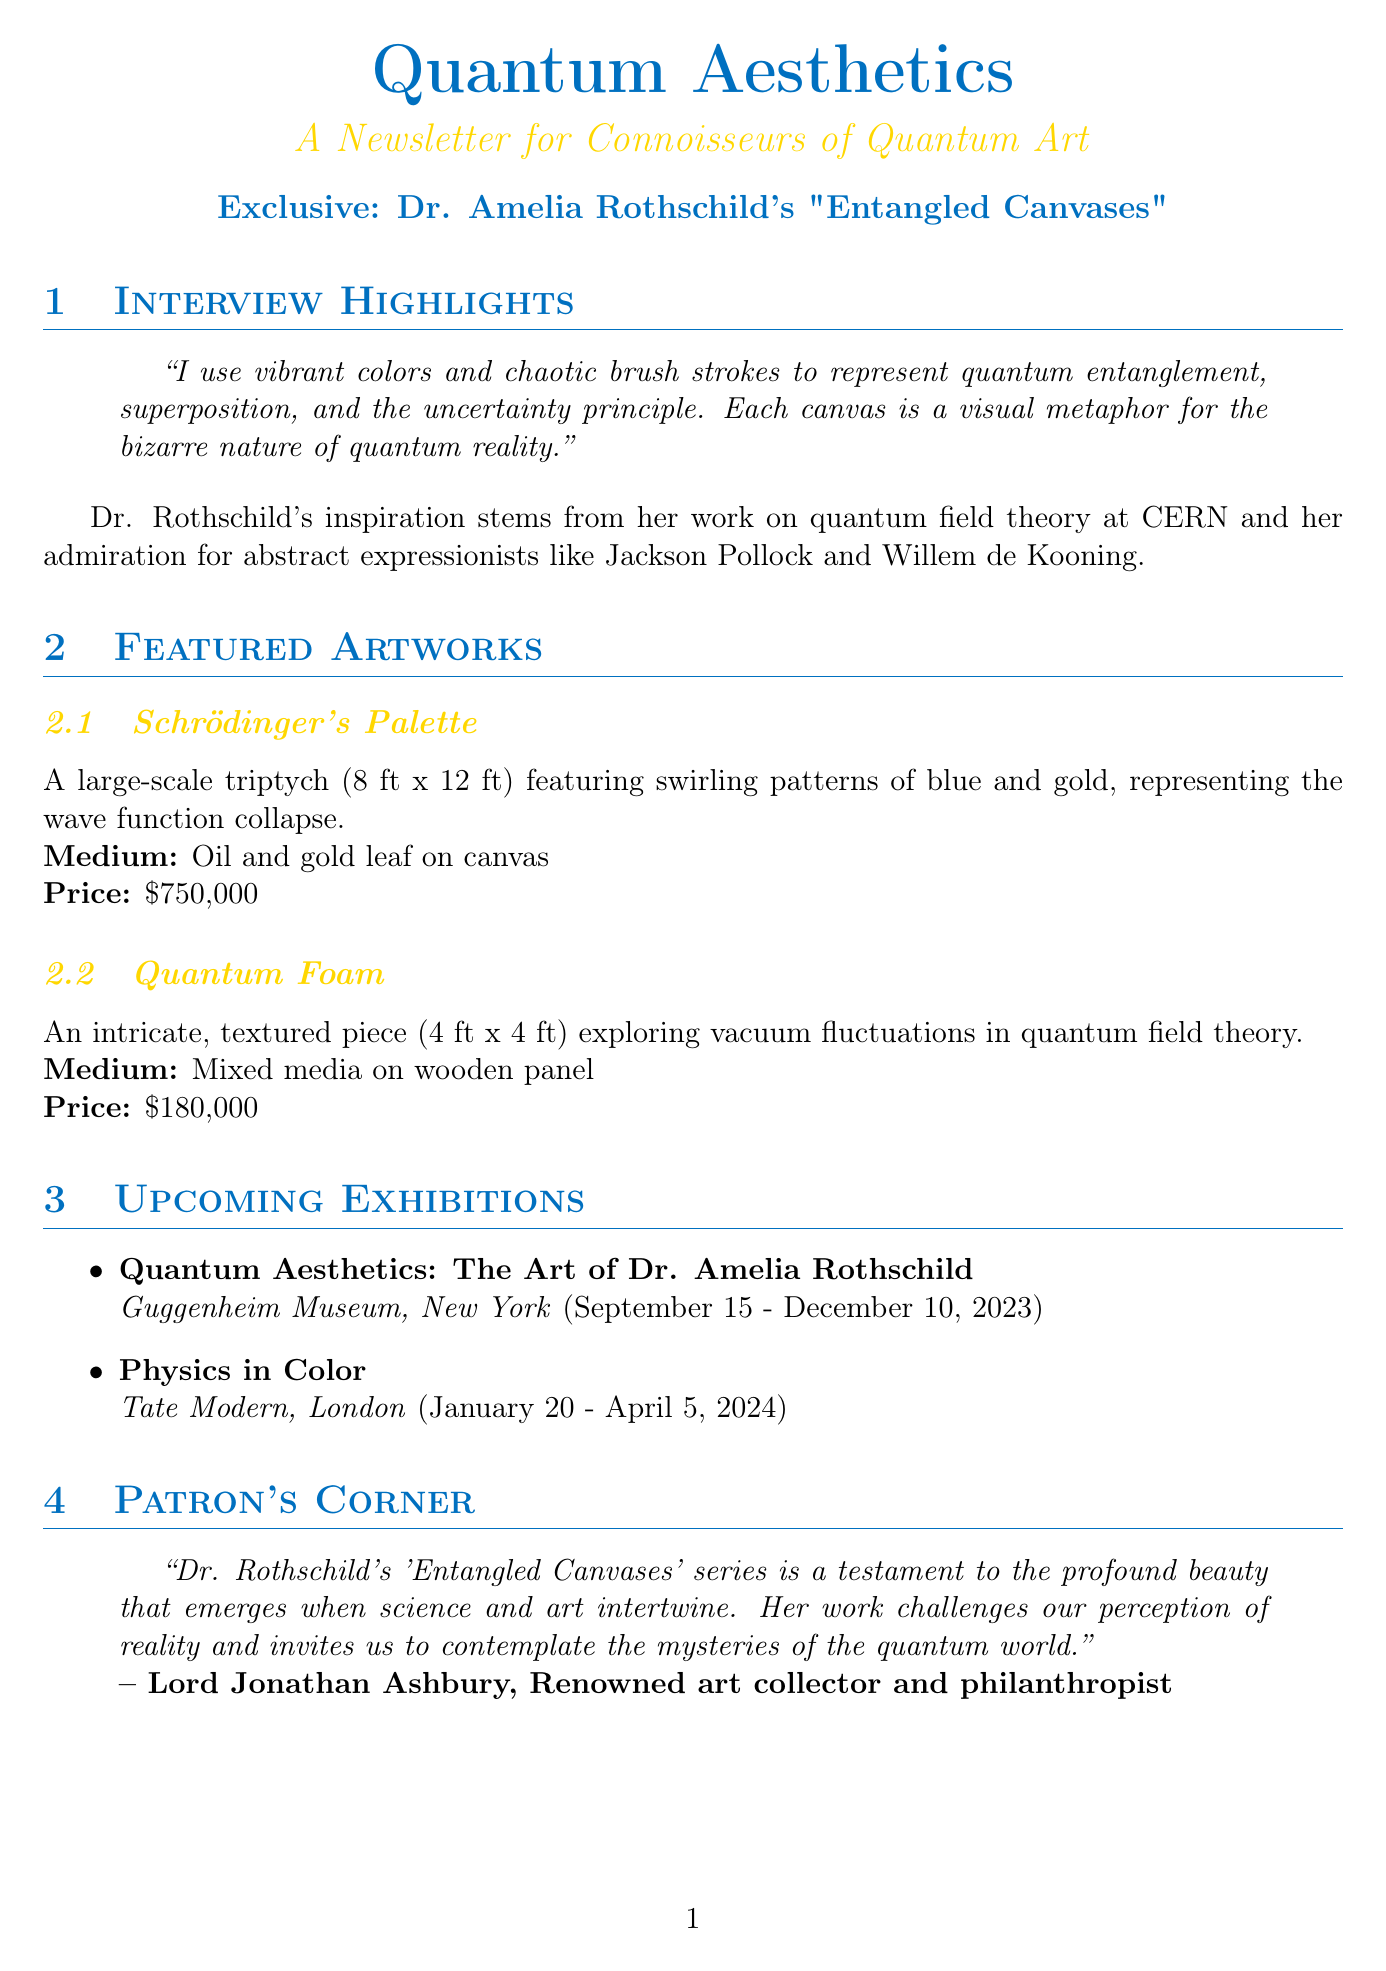What medium is used for "Schrödinger's Palette"? The medium is specified in the document as Oil and gold leaf on canvas.
Answer: Oil and gold leaf on canvas What are the dimensions of "Quantum Foam"? The dimensions are given in the document as 4 ft x 4 ft.
Answer: 4 ft x 4 ft When is the "Quantum Aesthetics" exhibition at the Guggenheim Museum? The date is provided in the document as September 15 - December 10, 2023.
Answer: September 15 - December 10, 2023 Who collaborated with Dr. Rothschild on the project "The Aesthetic of String Theory"? The document states that Dr. Brian Greene is the collaborator.
Answer: Dr. Brian Greene What does Dr. Rothschild's 'quantum randomness' technique influence? The document explains that it influences her color choices and brush strokes.
Answer: Color choices and brush strokes Why is Dr. Rothschild's work considered a good investment? The document notes that her pieces appreciate by an average of 25% annually.
Answer: 25% annually What is the price of "Schrödinger's Palette"? The price is mentioned in the document as $750,000.
Answer: $750,000 Who is the patron that provided a testimonial about Dr. Rothschild's work? The document identifies Lord Jonathan Ashbury as the patron.
Answer: Lord Jonathan Ashbury 